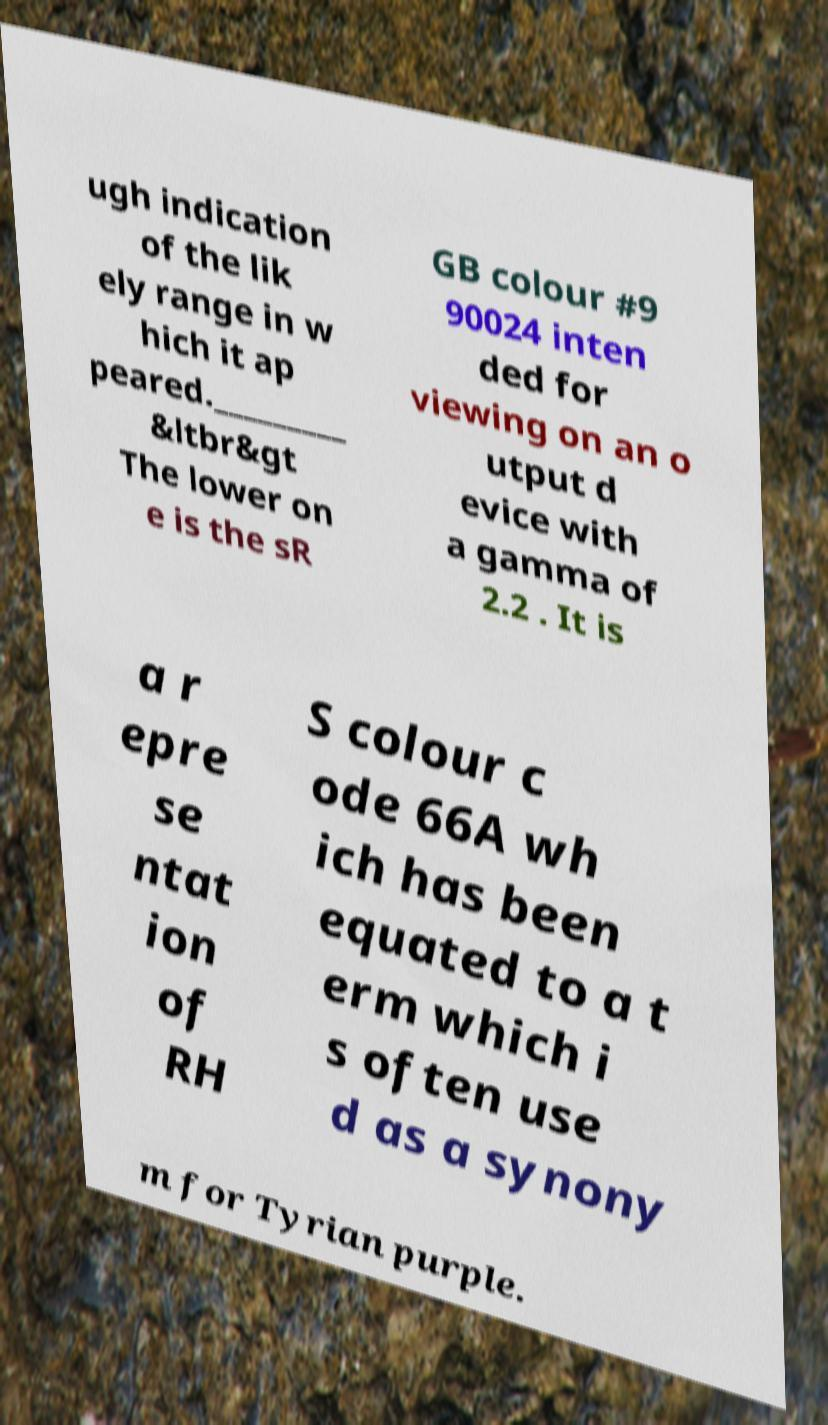What messages or text are displayed in this image? I need them in a readable, typed format. ugh indication of the lik ely range in w hich it ap peared._________ &ltbr&gt The lower on e is the sR GB colour #9 90024 inten ded for viewing on an o utput d evice with a gamma of 2.2 . It is a r epre se ntat ion of RH S colour c ode 66A wh ich has been equated to a t erm which i s often use d as a synony m for Tyrian purple. 